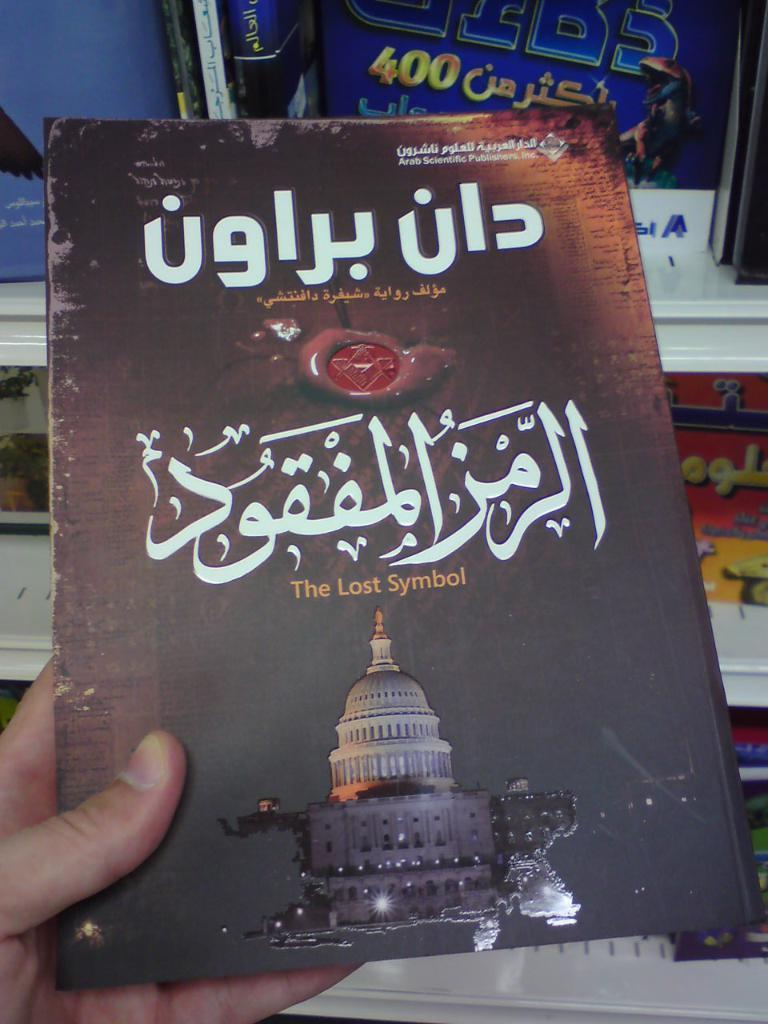<image>
Describe the image concisely. An old book with an image of the capital building saying The Lost Symbol. 